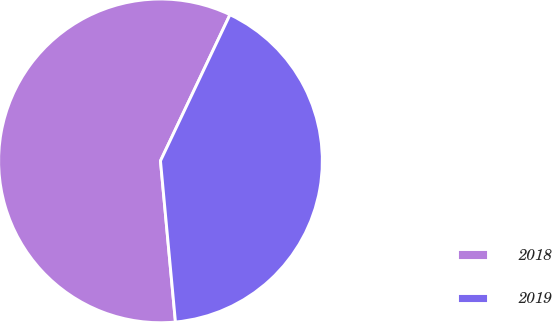Convert chart to OTSL. <chart><loc_0><loc_0><loc_500><loc_500><pie_chart><fcel>2018<fcel>2019<nl><fcel>58.54%<fcel>41.46%<nl></chart> 